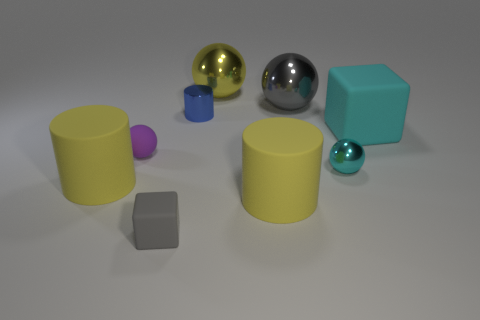Subtract 1 cylinders. How many cylinders are left? 2 Subtract all small cyan shiny spheres. How many spheres are left? 3 Subtract all gray balls. How many balls are left? 3 Subtract all green balls. Subtract all yellow cylinders. How many balls are left? 4 Add 1 small gray rubber objects. How many objects exist? 10 Subtract all cylinders. How many objects are left? 6 Add 3 matte balls. How many matte balls are left? 4 Add 2 rubber cubes. How many rubber cubes exist? 4 Subtract 0 purple blocks. How many objects are left? 9 Subtract all small blue cylinders. Subtract all yellow matte objects. How many objects are left? 6 